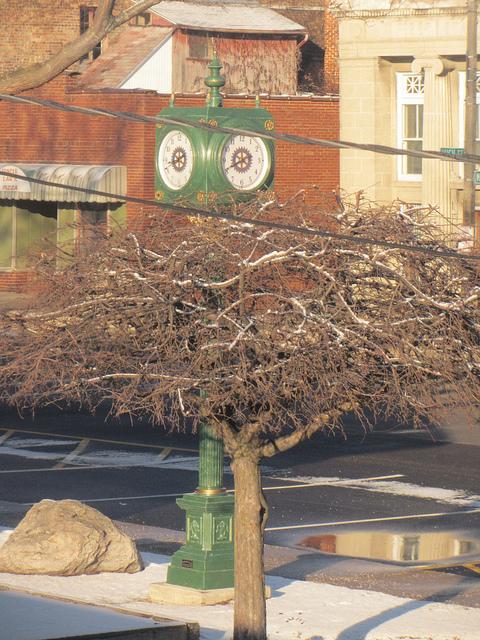Are there leaves on the tree?
Give a very brief answer. No. Is the clocks time visible?
Answer briefly. No. How many hands does the clock have?
Concise answer only. 2. 